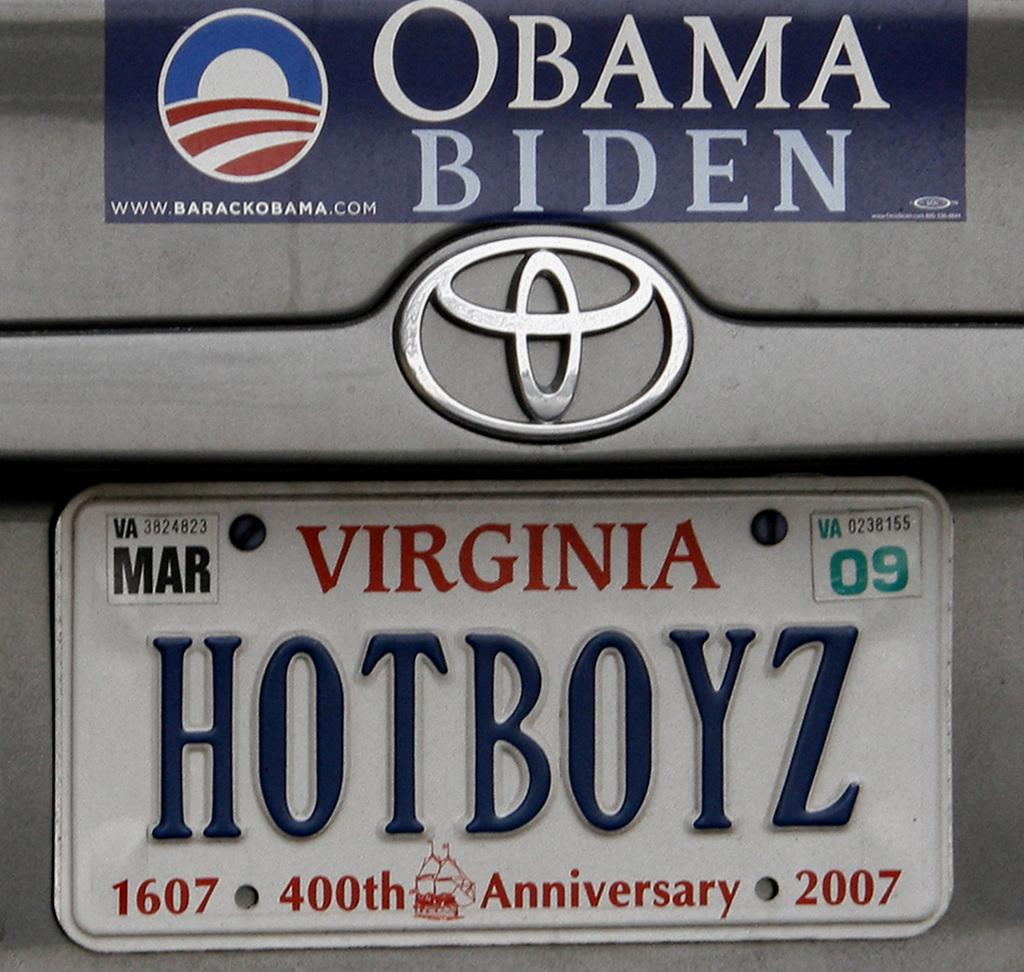<image>
Relay a brief, clear account of the picture shown. A silver Toyota has an Obama Biden bumper sticker above the license plate. 